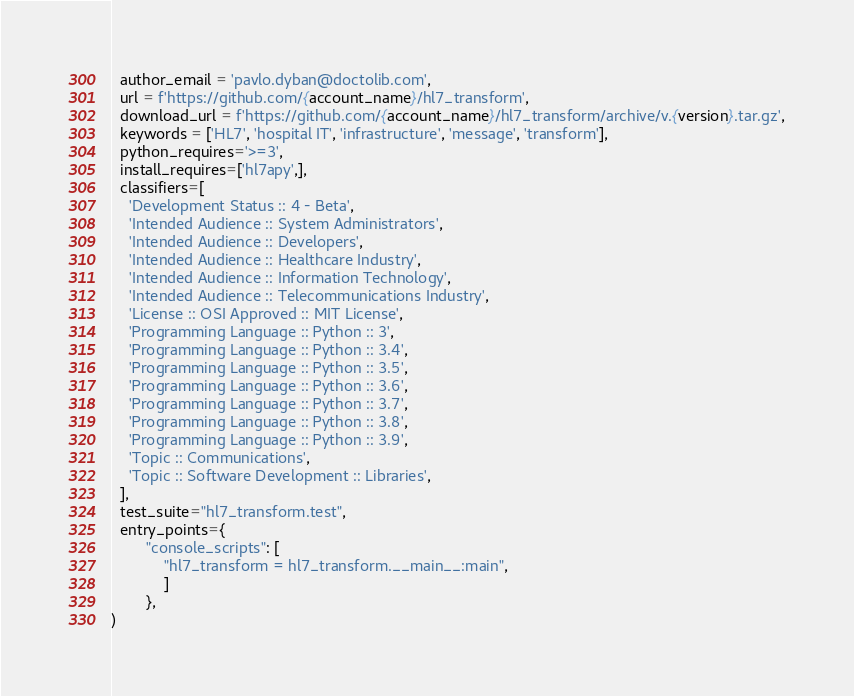Convert code to text. <code><loc_0><loc_0><loc_500><loc_500><_Python_>  author_email = 'pavlo.dyban@doctolib.com',
  url = f'https://github.com/{account_name}/hl7_transform',
  download_url = f'https://github.com/{account_name}/hl7_transform/archive/v.{version}.tar.gz',
  keywords = ['HL7', 'hospital IT', 'infrastructure', 'message', 'transform'],
  python_requires='>=3',
  install_requires=['hl7apy',],
  classifiers=[
    'Development Status :: 4 - Beta',
    'Intended Audience :: System Administrators',
    'Intended Audience :: Developers',
    'Intended Audience :: Healthcare Industry',
    'Intended Audience :: Information Technology',
    'Intended Audience :: Telecommunications Industry',
    'License :: OSI Approved :: MIT License',
    'Programming Language :: Python :: 3',
    'Programming Language :: Python :: 3.4',
    'Programming Language :: Python :: 3.5',
    'Programming Language :: Python :: 3.6',
    'Programming Language :: Python :: 3.7',
    'Programming Language :: Python :: 3.8',
    'Programming Language :: Python :: 3.9',
    'Topic :: Communications',
    'Topic :: Software Development :: Libraries',
  ],
  test_suite="hl7_transform.test",
  entry_points={
        "console_scripts": [
            "hl7_transform = hl7_transform.__main__:main",
            ]
        },
)
</code> 